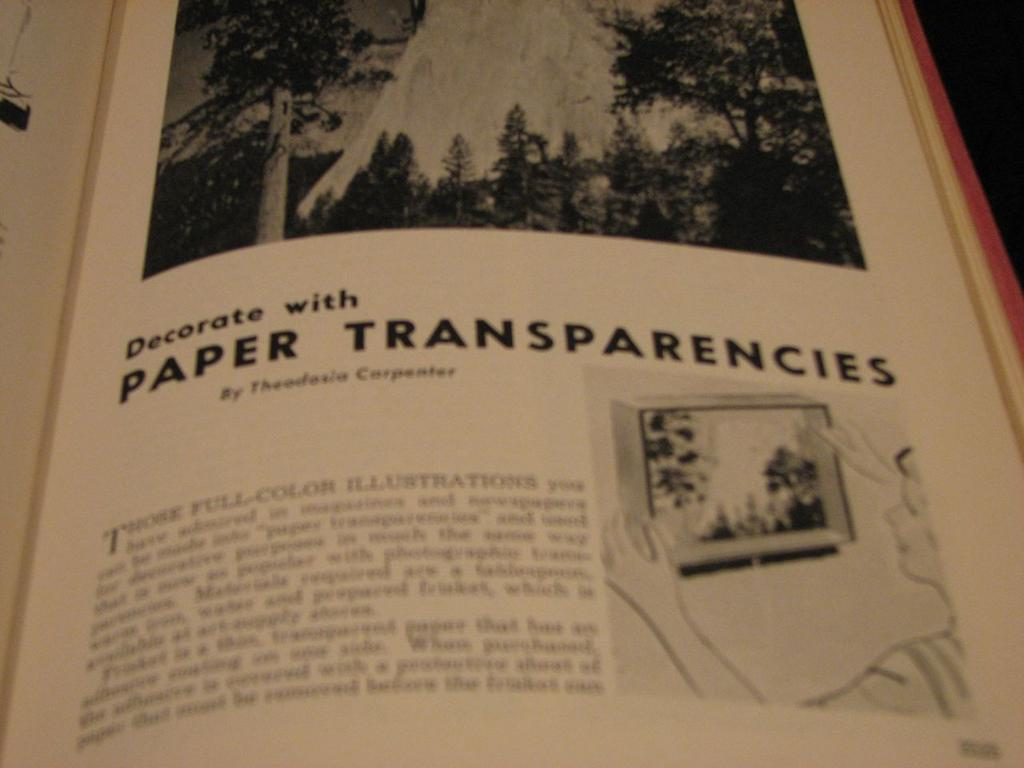<image>
Present a compact description of the photo's key features. A book is open to an article on decorating with paper transparencies. 